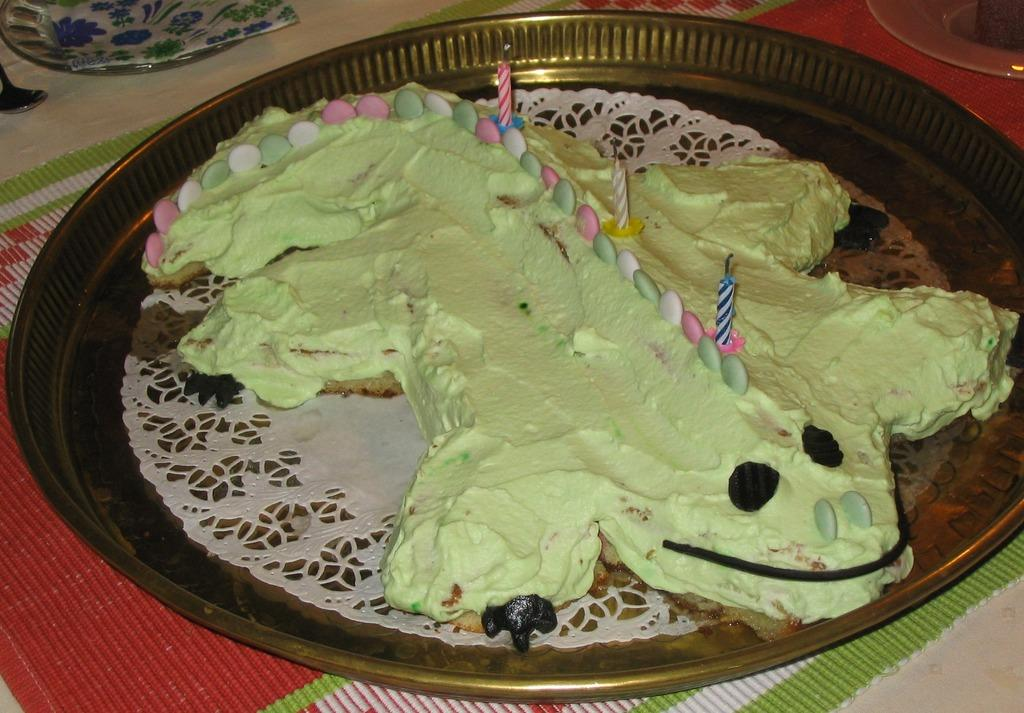What is the main subject of the image? The main subject of the image is a cake. What decorations are on the cake? The cake has gems and candles on it. What other objects are visible in the image? There is a plate, a spoon, a paper, and an object that looks like a mat in the image. What type of protest is taking place in the image? There is no protest present in the image; it features a cake with gems and candles, along with other objects. Can you tell me the flight number of the airplane in the image? There is no airplane present in the image; it features a cake with gems and candles, along with other objects. 